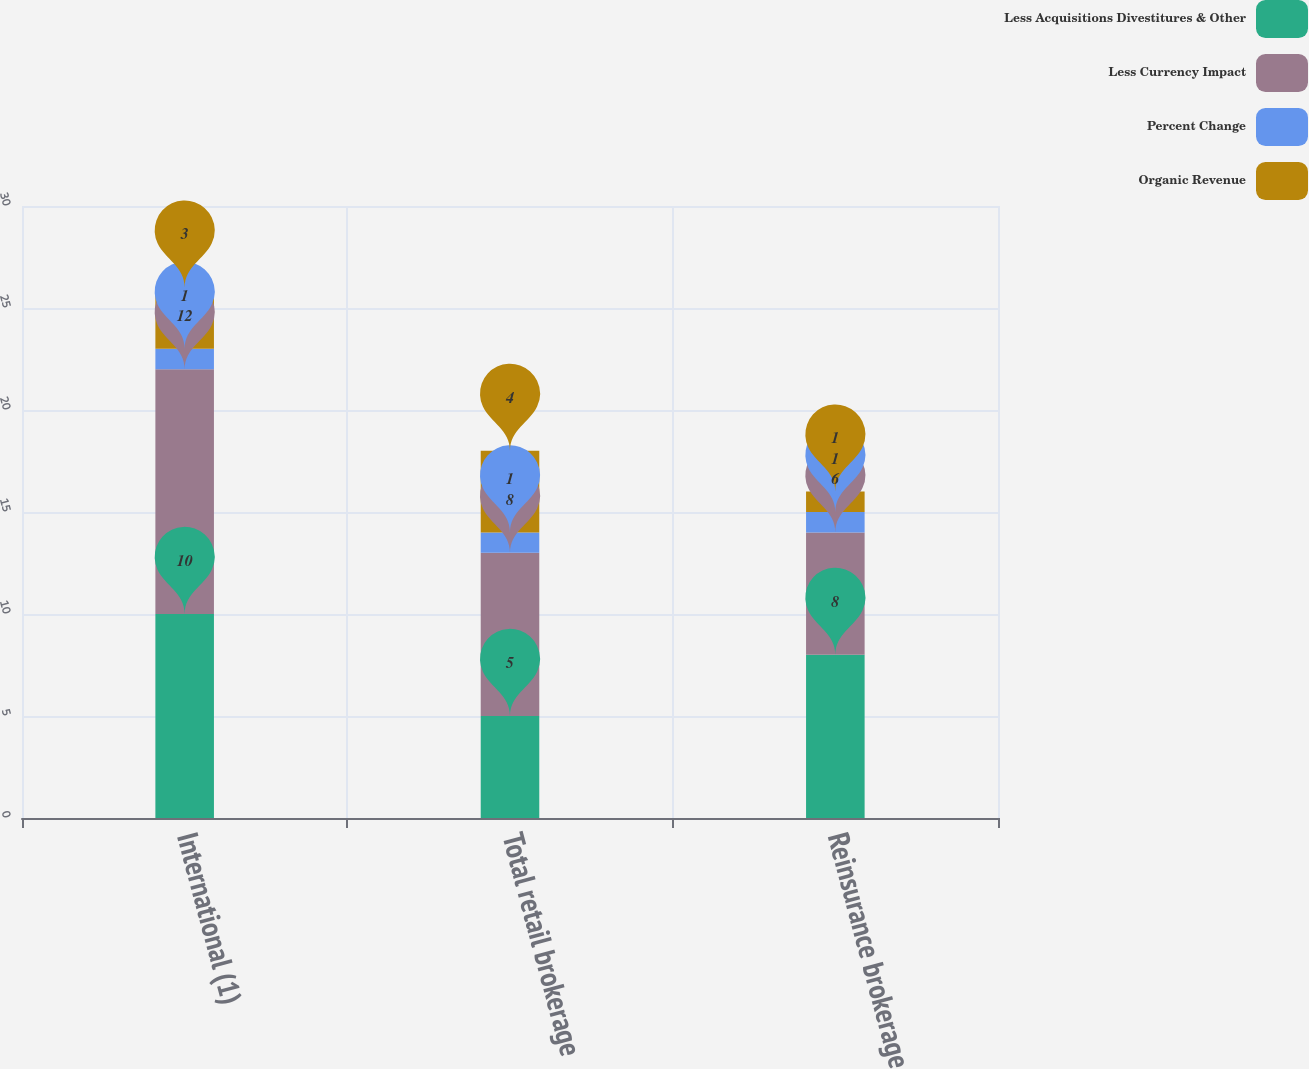<chart> <loc_0><loc_0><loc_500><loc_500><stacked_bar_chart><ecel><fcel>International (1)<fcel>Total retail brokerage<fcel>Reinsurance brokerage<nl><fcel>Less Acquisitions Divestitures & Other<fcel>10<fcel>5<fcel>8<nl><fcel>Less Currency Impact<fcel>12<fcel>8<fcel>6<nl><fcel>Percent Change<fcel>1<fcel>1<fcel>1<nl><fcel>Organic Revenue<fcel>3<fcel>4<fcel>1<nl></chart> 